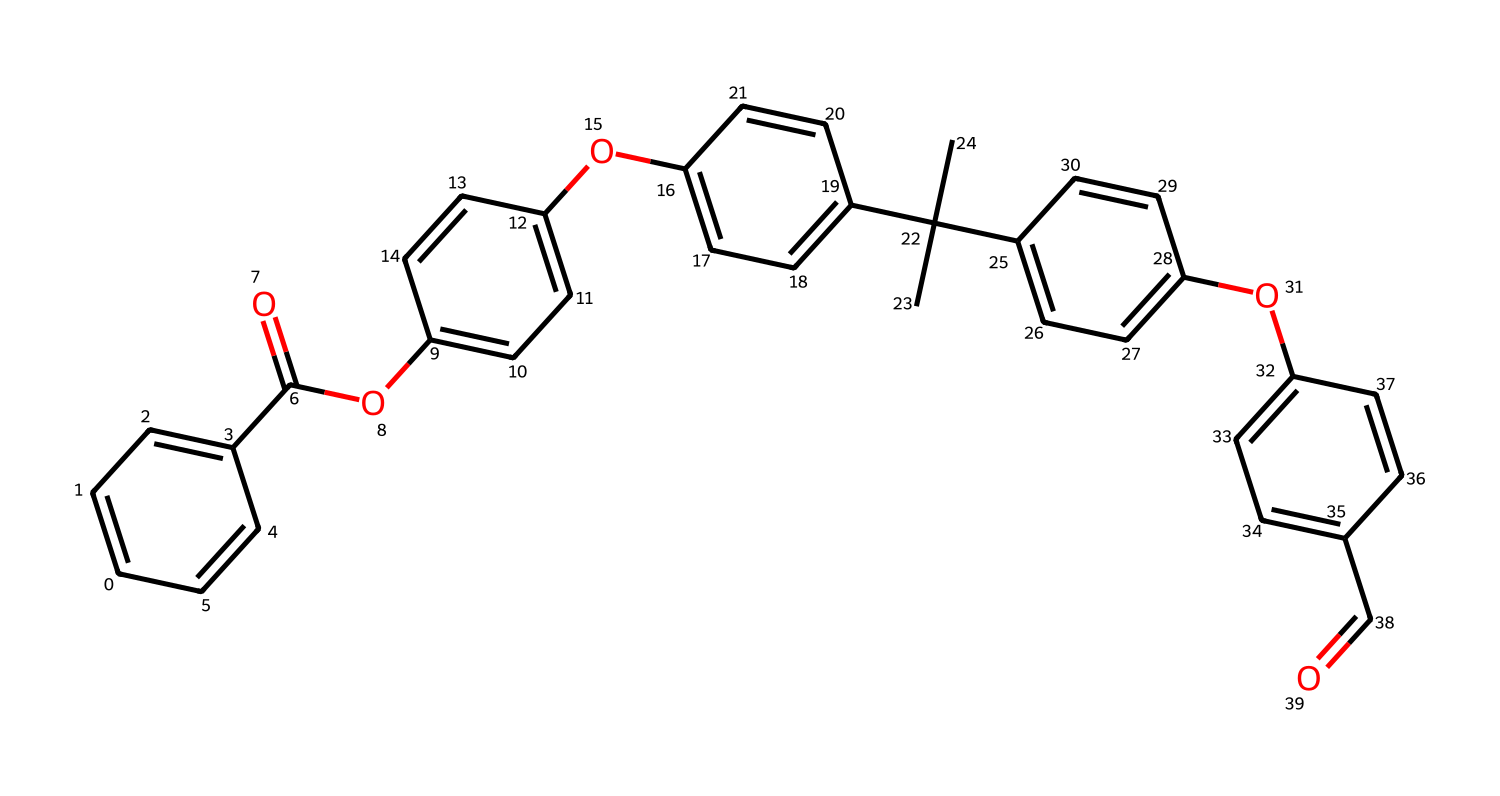What is the overall molecular formula of this compound? To determine the molecular formula, you need to count the number of each type of atom present in the structure from the SMILES string. By analyzing the structure, you find there are 30 carbon atoms (c), 28 hydrogen atoms (H), and 4 oxygen atoms (O). Thus, the overall molecular formula is C30H28O4.
Answer: C30H28O4 How many aromatic rings are present in the structure? Count the number of distinct benzene rings in the structure represented by the 'c' characters in the SMILES which indicates aromatic carbons. From the analysis, you can delineate five aromatic rings in the given structure.
Answer: 5 What types of functional groups are present in this compound? Look for indicative parts of the structure such as 'C(=O)' for carbonyls and 'O' for ethers or esters. In this compound, you find esters (-O-C=O groups) and phenolic hydroxyl (-OH) groups present in the structure.
Answer: ester, phenol Can this compound withstand deep-sea pressures? Considering the stability and rigidity provided by the aromaticity and polymer structure, you can infer that this compound's structure is likely designed to withstand significant pressures, typical of deep-sea environments where such materials are employed in submarine technology.
Answer: yes What is the significance of the branched alkyl group in this structure? The branched alkyl groups (like C(C)(C)) provide steric hindrance and increase the overall hydrophobicity, which is crucial for polymer applications in underwater vehicles as they enhance resistance to water absorption and pressure.
Answer: enhances hydrophobicity How does this structure exhibit its aromatic properties? The aromatic character is asserted through the presence of alternating double bonds within the cyclic structures, creating a resonance stability that is characteristic of aromatic compounds. All the rings are connected by aromatic bonds.
Answer: resonance stability 